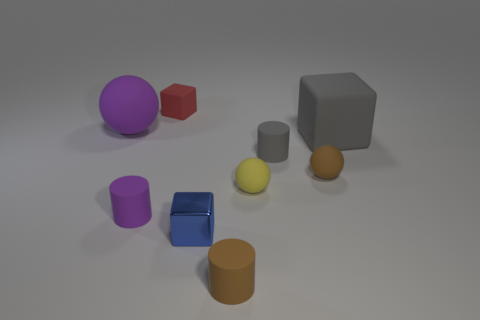How many other objects are there of the same shape as the tiny blue shiny thing?
Offer a terse response. 2. Does the tiny sphere that is on the left side of the brown sphere have the same material as the brown object that is right of the small gray matte object?
Offer a terse response. Yes. What number of other objects are there of the same size as the blue cube?
Your response must be concise. 6. What number of objects are either tiny cyan objects or small brown rubber objects in front of the small yellow matte thing?
Make the answer very short. 1. Are there the same number of tiny gray rubber cylinders that are on the left side of the red cube and small green matte objects?
Make the answer very short. Yes. There is a red object that is the same material as the tiny yellow object; what is its shape?
Your response must be concise. Cube. Are there any matte objects of the same color as the large block?
Provide a succinct answer. Yes. What number of metal things are either green blocks or brown spheres?
Offer a very short reply. 0. There is a big object that is on the left side of the purple rubber cylinder; what number of small matte things are in front of it?
Your answer should be compact. 5. How many small balls have the same material as the small purple thing?
Your response must be concise. 2. 